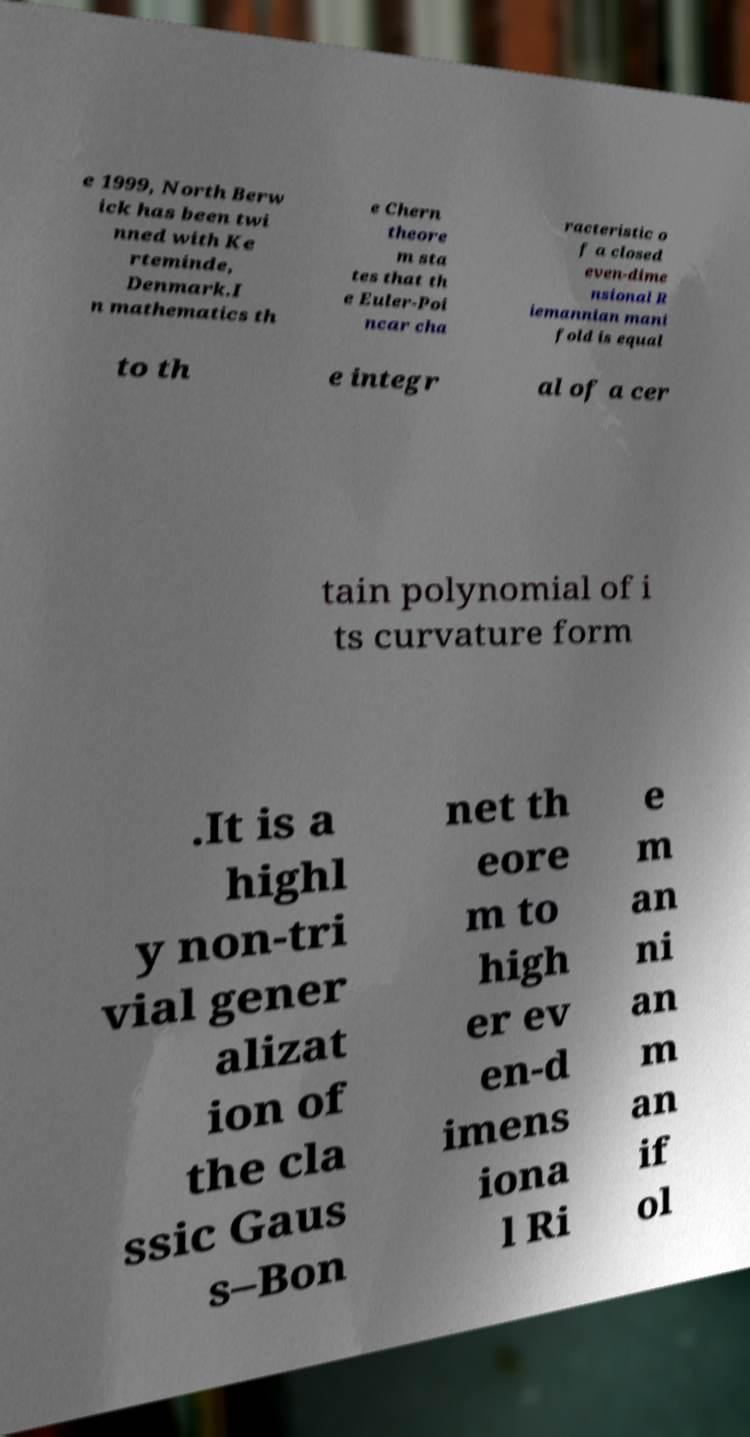Please read and relay the text visible in this image. What does it say? e 1999, North Berw ick has been twi nned with Ke rteminde, Denmark.I n mathematics th e Chern theore m sta tes that th e Euler-Poi ncar cha racteristic o f a closed even-dime nsional R iemannian mani fold is equal to th e integr al of a cer tain polynomial of i ts curvature form .It is a highl y non-tri vial gener alizat ion of the cla ssic Gaus s–Bon net th eore m to high er ev en-d imens iona l Ri e m an ni an m an if ol 